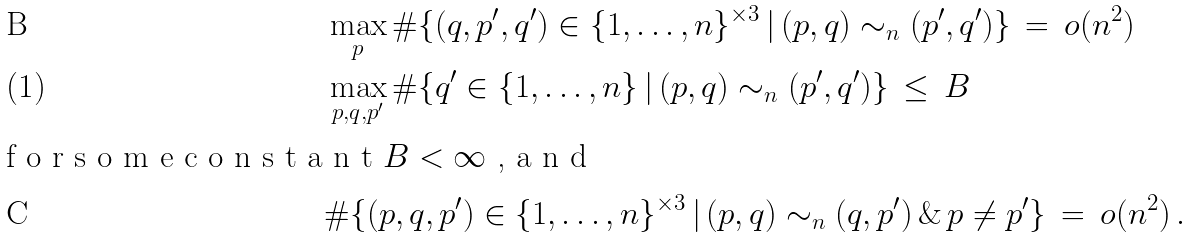<formula> <loc_0><loc_0><loc_500><loc_500>& \max _ { p } \# \{ ( q , p ^ { \prime } , q ^ { \prime } ) \in \{ 1 , \dots , n \} ^ { \times 3 } \, | \, ( p , q ) \sim _ { n } ( p ^ { \prime } , q ^ { \prime } ) \} \, = \, o ( n ^ { 2 } ) \\ & \max _ { p , q , p ^ { \prime } } \# \{ q ^ { \prime } \in \{ 1 , \dots , n \} \, | \, ( p , q ) \sim _ { n } ( p ^ { \prime } , q ^ { \prime } ) \} \, \leq \, B \, \intertext { f o r s o m e c o n s t a n t $ B < \infty $ , a n d } & \# \{ ( p , q , p ^ { \prime } ) \in \{ 1 , \dots , n \} ^ { \times 3 } \, | \, ( p , q ) \sim _ { n } ( q , p ^ { \prime } ) \, \& \, p \neq p ^ { \prime } \} \, = \, o ( n ^ { 2 } ) \, .</formula> 